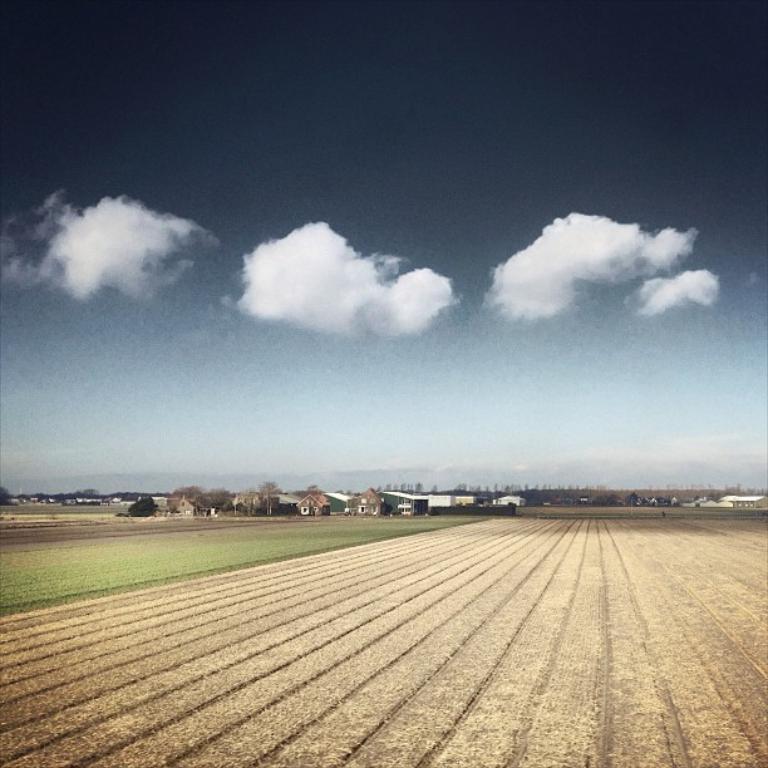Could you give a brief overview of what you see in this image? In this picture I can observe an open land. There are houses in the background and I can observe some clouds in the sky. 